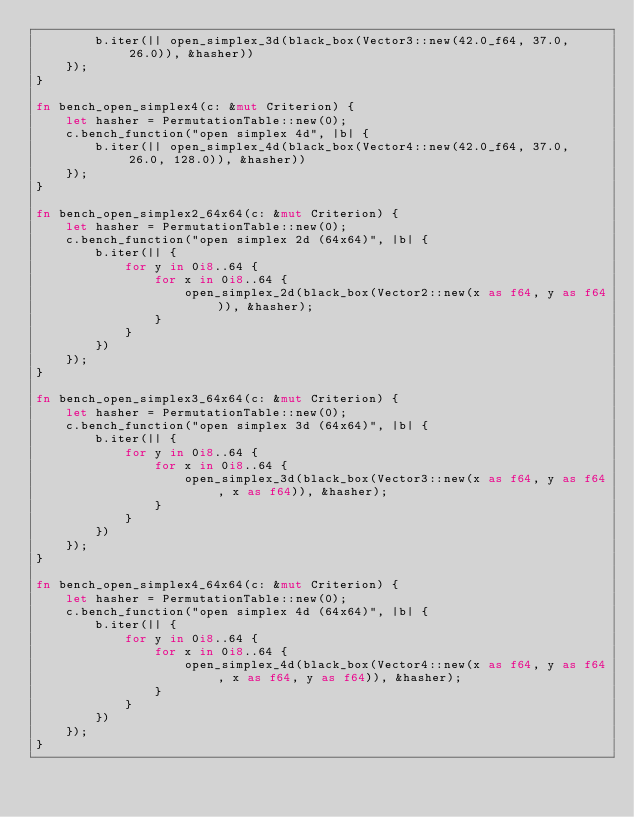<code> <loc_0><loc_0><loc_500><loc_500><_Rust_>        b.iter(|| open_simplex_3d(black_box(Vector3::new(42.0_f64, 37.0, 26.0)), &hasher))
    });
}

fn bench_open_simplex4(c: &mut Criterion) {
    let hasher = PermutationTable::new(0);
    c.bench_function("open simplex 4d", |b| {
        b.iter(|| open_simplex_4d(black_box(Vector4::new(42.0_f64, 37.0, 26.0, 128.0)), &hasher))
    });
}

fn bench_open_simplex2_64x64(c: &mut Criterion) {
    let hasher = PermutationTable::new(0);
    c.bench_function("open simplex 2d (64x64)", |b| {
        b.iter(|| {
            for y in 0i8..64 {
                for x in 0i8..64 {
                    open_simplex_2d(black_box(Vector2::new(x as f64, y as f64)), &hasher);
                }
            }
        })
    });
}

fn bench_open_simplex3_64x64(c: &mut Criterion) {
    let hasher = PermutationTable::new(0);
    c.bench_function("open simplex 3d (64x64)", |b| {
        b.iter(|| {
            for y in 0i8..64 {
                for x in 0i8..64 {
                    open_simplex_3d(black_box(Vector3::new(x as f64, y as f64, x as f64)), &hasher);
                }
            }
        })
    });
}

fn bench_open_simplex4_64x64(c: &mut Criterion) {
    let hasher = PermutationTable::new(0);
    c.bench_function("open simplex 4d (64x64)", |b| {
        b.iter(|| {
            for y in 0i8..64 {
                for x in 0i8..64 {
                    open_simplex_4d(black_box(Vector4::new(x as f64, y as f64, x as f64, y as f64)), &hasher);
                }
            }
        })
    });
}
</code> 